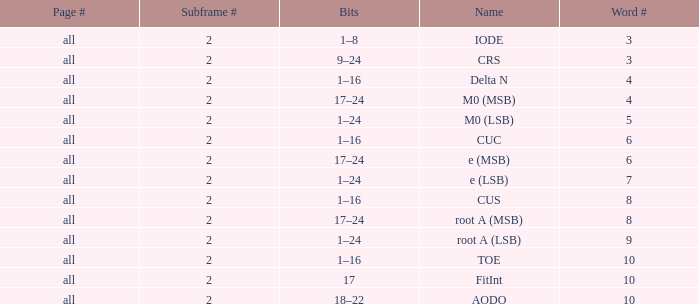What is the total subframe count with Bits of 18–22? 2.0. 